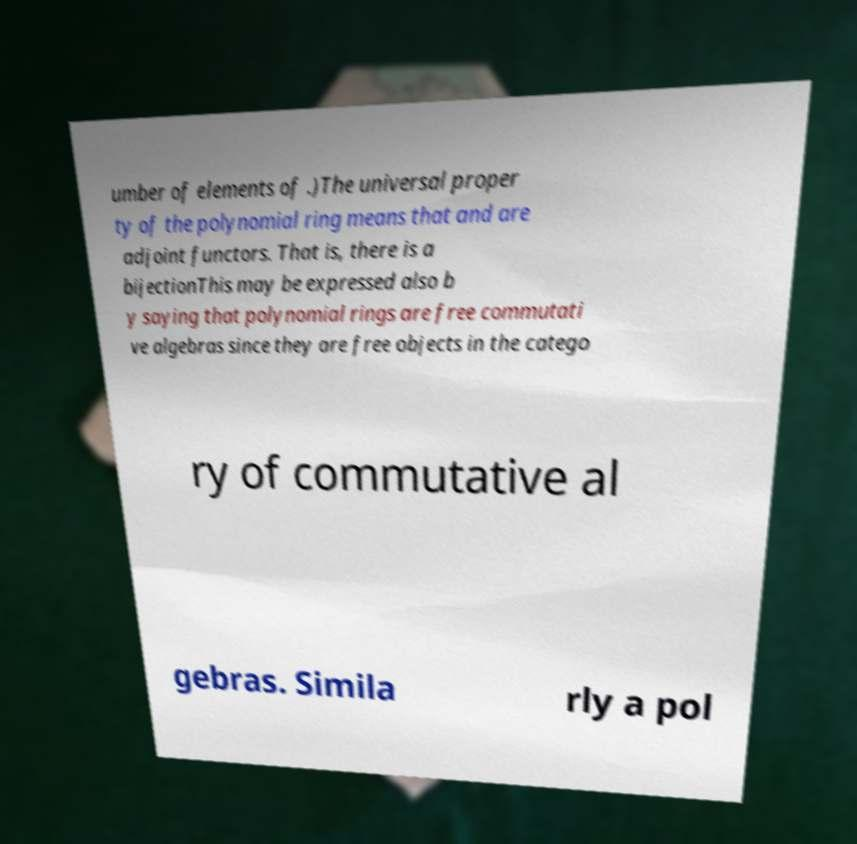Could you assist in decoding the text presented in this image and type it out clearly? umber of elements of .)The universal proper ty of the polynomial ring means that and are adjoint functors. That is, there is a bijectionThis may be expressed also b y saying that polynomial rings are free commutati ve algebras since they are free objects in the catego ry of commutative al gebras. Simila rly a pol 